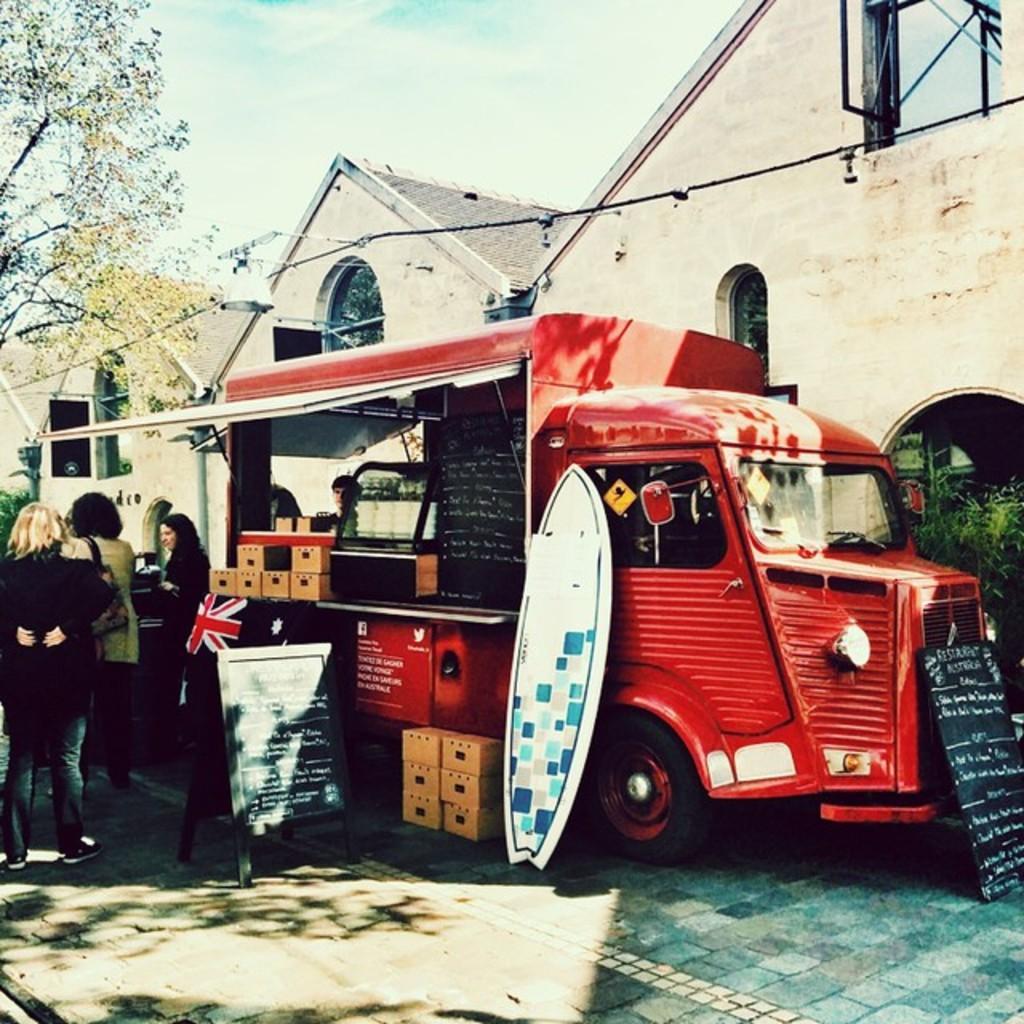In one or two sentences, can you explain what this image depicts? In the foreground of this picture, there is a vehicle placed side to the road and also surfboard, boxes, black boards and few persons are standing on the road. In the background, there are trees, buildings, and the sky. 